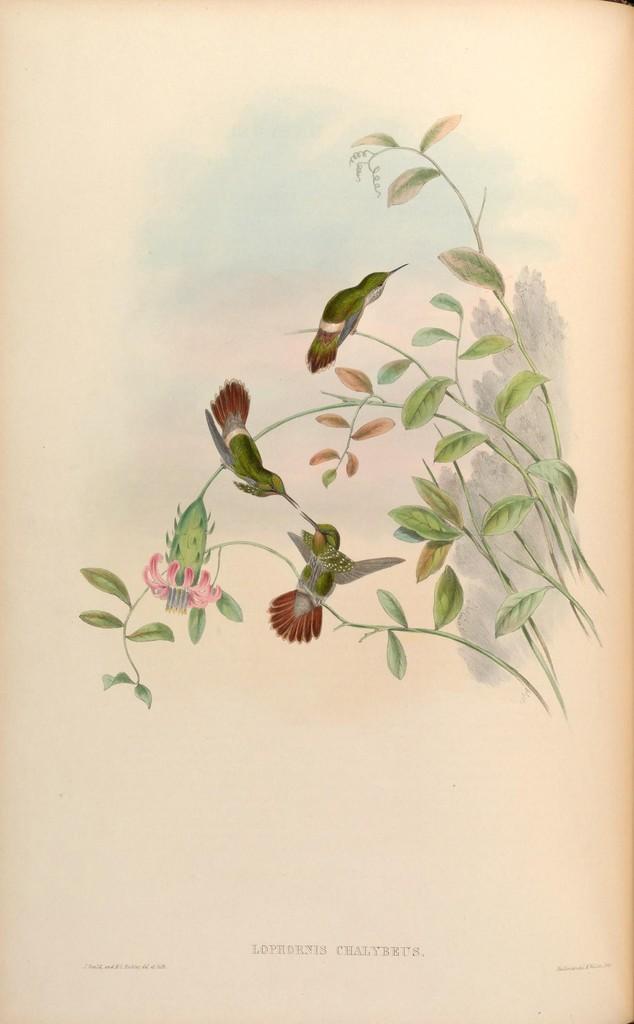How would you summarize this image in a sentence or two? In the picture there is a painting of few birds standing on the branches of a plant. 